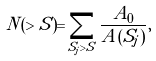Convert formula to latex. <formula><loc_0><loc_0><loc_500><loc_500>N ( > S ) = \sum _ { S _ { j } > S } { \frac { A _ { 0 } } { A ( S _ { j } ) } } ,</formula> 